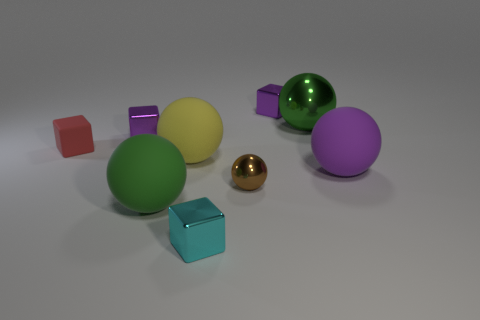There is a tiny purple block on the right side of the tiny purple metal block left of the cyan thing; how many purple things are to the right of it?
Ensure brevity in your answer.  1. There is a big object that is behind the yellow rubber object; is it the same shape as the small brown shiny object?
Offer a terse response. Yes. There is a small cube that is on the right side of the tiny brown shiny sphere; what is it made of?
Offer a terse response. Metal. There is a large object that is both behind the purple rubber sphere and to the left of the green shiny thing; what shape is it?
Your response must be concise. Sphere. What is the material of the large yellow sphere?
Provide a succinct answer. Rubber. How many cylinders are either big matte things or matte objects?
Give a very brief answer. 0. Are the cyan block and the tiny sphere made of the same material?
Your answer should be compact. Yes. The brown metal thing that is the same shape as the large purple matte object is what size?
Make the answer very short. Small. There is a tiny object that is to the left of the small brown metal ball and in front of the purple matte object; what material is it?
Give a very brief answer. Metal. Are there the same number of rubber balls that are to the left of the tiny red thing and tiny red matte things?
Give a very brief answer. No. 